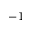<formula> <loc_0><loc_0><loc_500><loc_500>^ { - 1 }</formula> 